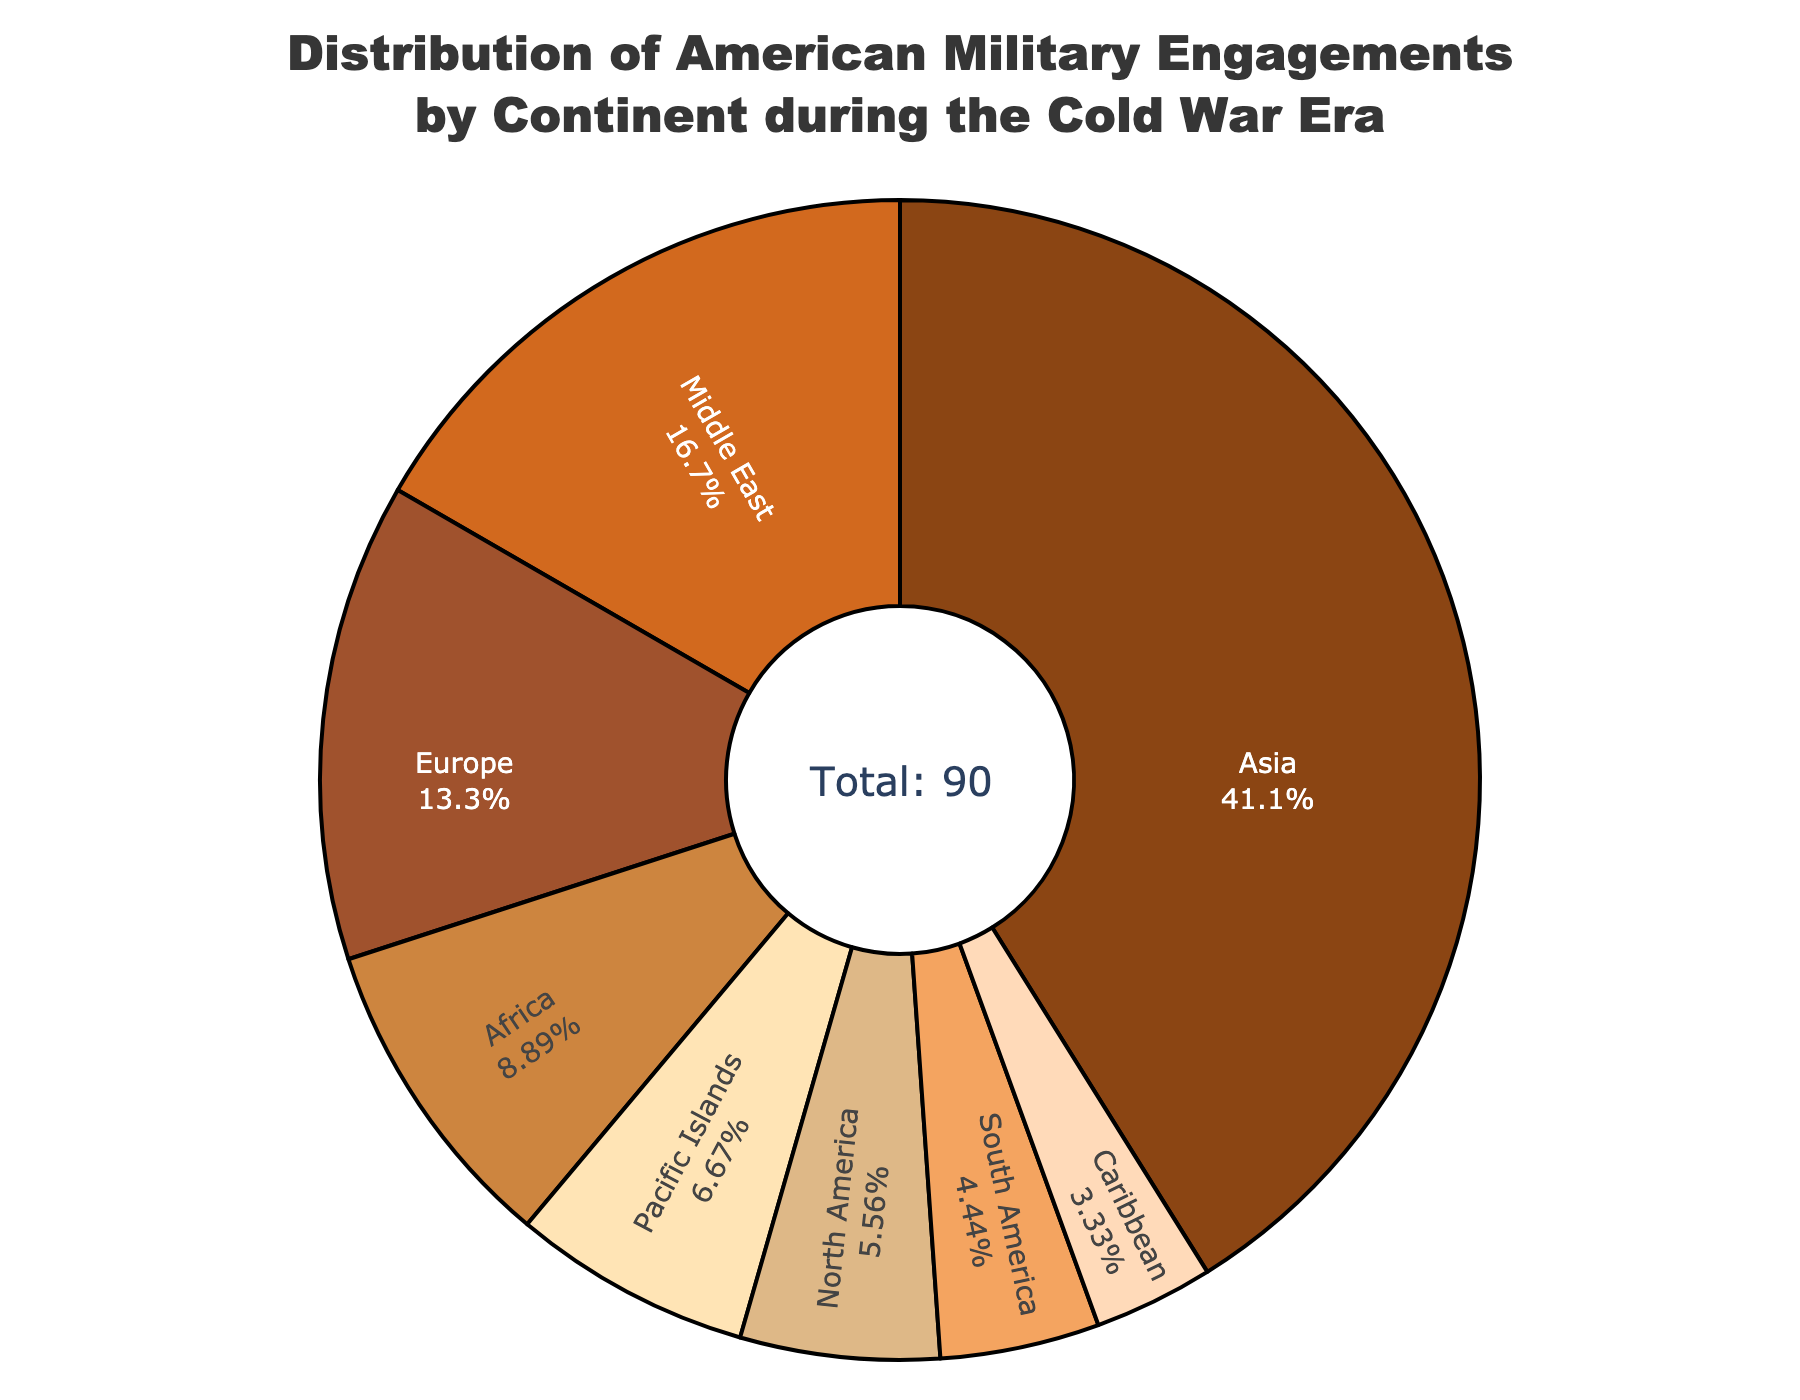What percentage of American military engagements during the Cold War era took place in Asia? From the figure, the "Asia" portion of the pie chart is shown with its percentage values. It is 37 engagements out of the total number of 90 engagements. The percentage can be confirmed directly from this segment.
Answer: 41.1% Which continent had the least number of American military engagements during the Cold War era? The "Caribbean" segment in the pie chart is the smallest slice, indicating it has the least number of engagements. The label shows 3 engagements.
Answer: Caribbean How does the number of engagements in Europe compare to those in the Middle East? The figure shows 12 engagements in Europe and 15 engagements in the Middle East, as indicated by their respective segments in the pie chart. Comparing these numbers, Europe has fewer engagements than the Middle East.
Answer: Middle East has more What is the total number of American military engagements during the Cold War era depicted in the figure? Adding up all the numbers from each segment in the pie chart gives the total number of engagements. The number can also be identified from the central annotation of the pie chart showing "Total: 90."
Answer: 90 How many more engagements were there in Asia compared to Africa? The pie chart shows 37 engagements in Asia and 8 in Africa. Subtracting the number of engagements in Africa from those in Asia gives: 37 - 8 = 29 more engagements in Asia.
Answer: 29 more Which continents had fewer than 10 American military engagements during the Cold War era? From the pie chart, the segments for North America, South America, Caribbean, and Pacific Islands show engagement numbers less than 10: 5, 4, 3, and 6, respectively.
Answer: North America, South America, Caribbean, Pacific Islands What is the combined percentage of engagements for the Middle East and Africa? The pie chart indicates 15 engagements for the Middle East and 8 engagements for Africa. First, sum these numbers: 15 + 8 = 23. Then calculate the percentage of the total engagements: (23 / 90) * 100 ≈ 25.6%.
Answer: 25.6% Which continent saw approximately one-third (or 33.3%) of the total military engagements? By examining the pie chart, Asia's segment shows it had 37 engagements. Calculating the percentage: (37 / 90) * 100 ≈ 41.1%, which is closest to one-third of the total engagements.
Answer: Asia 